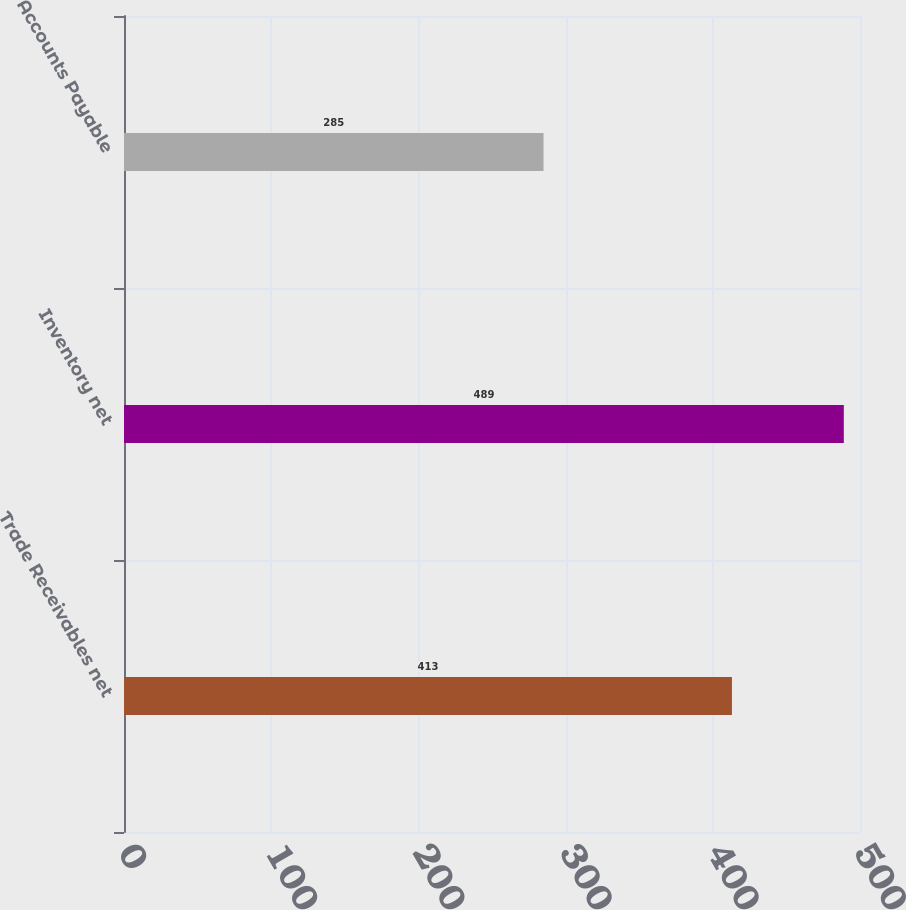<chart> <loc_0><loc_0><loc_500><loc_500><bar_chart><fcel>Trade Receivables net<fcel>Inventory net<fcel>Accounts Payable<nl><fcel>413<fcel>489<fcel>285<nl></chart> 